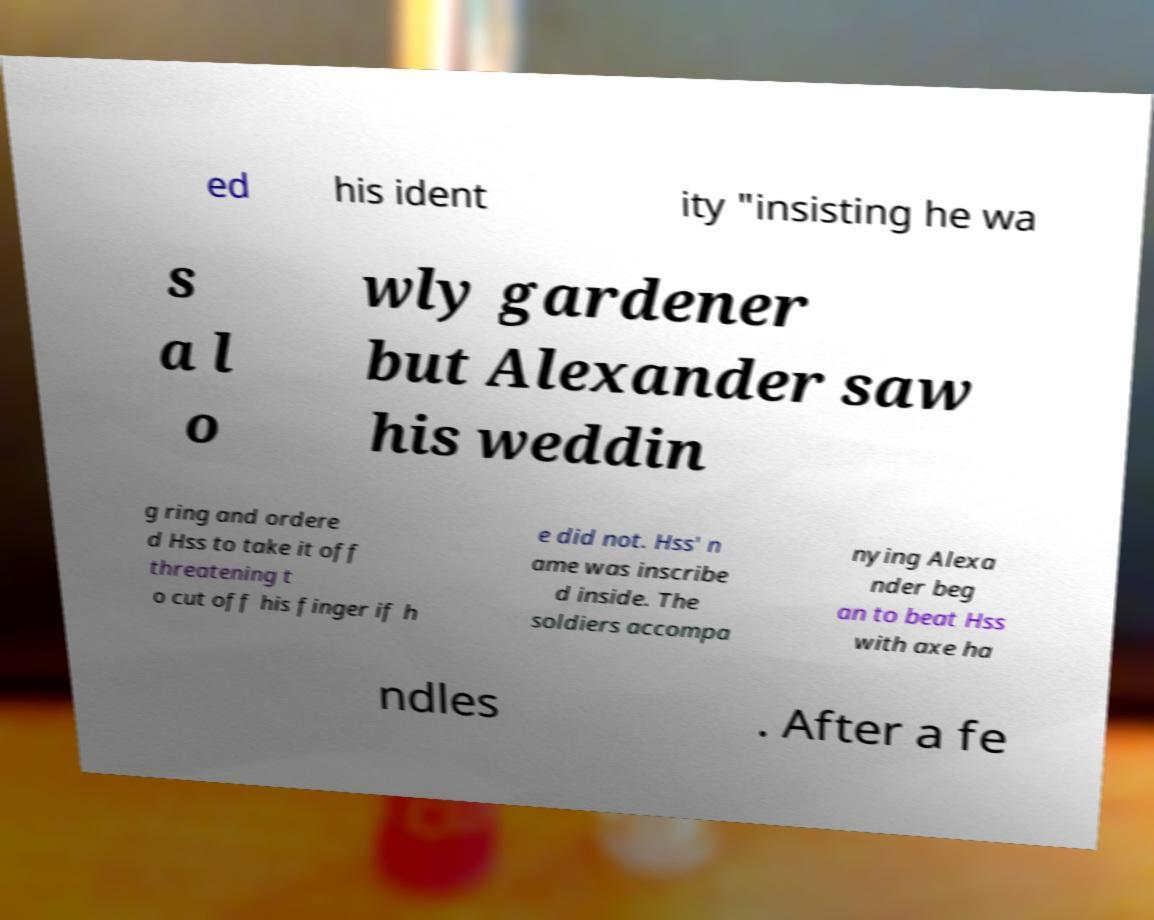Can you read and provide the text displayed in the image?This photo seems to have some interesting text. Can you extract and type it out for me? ed his ident ity "insisting he wa s a l o wly gardener but Alexander saw his weddin g ring and ordere d Hss to take it off threatening t o cut off his finger if h e did not. Hss' n ame was inscribe d inside. The soldiers accompa nying Alexa nder beg an to beat Hss with axe ha ndles . After a fe 